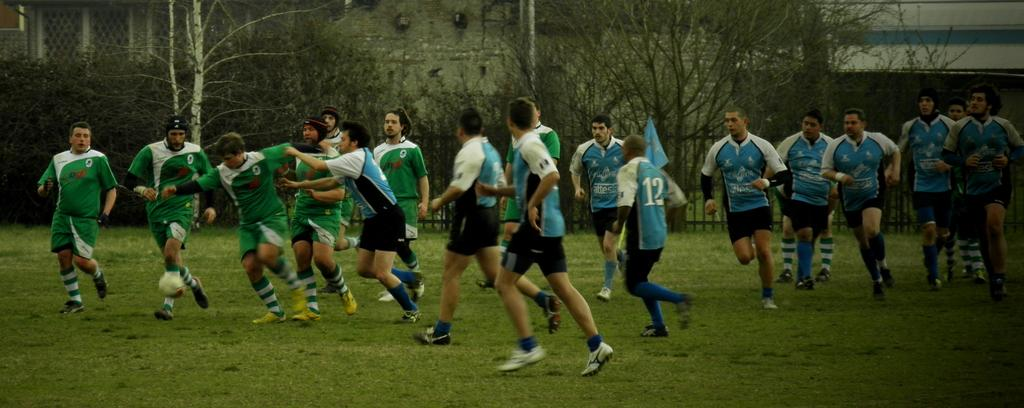What is happening in the image involving the group of people? The people in the image are running. What colors are the dresses of the people in the image? The people are wearing blue, white, black, and green color dresses. What can be seen in the background of the image? There are trees, fencing, and a building visible in the background. What type of volleyball game is being played in the image? There is no volleyball game present in the image; the people are running. How much does the bird weigh in the image? There is no bird present in the image, so its weight cannot be determined. 